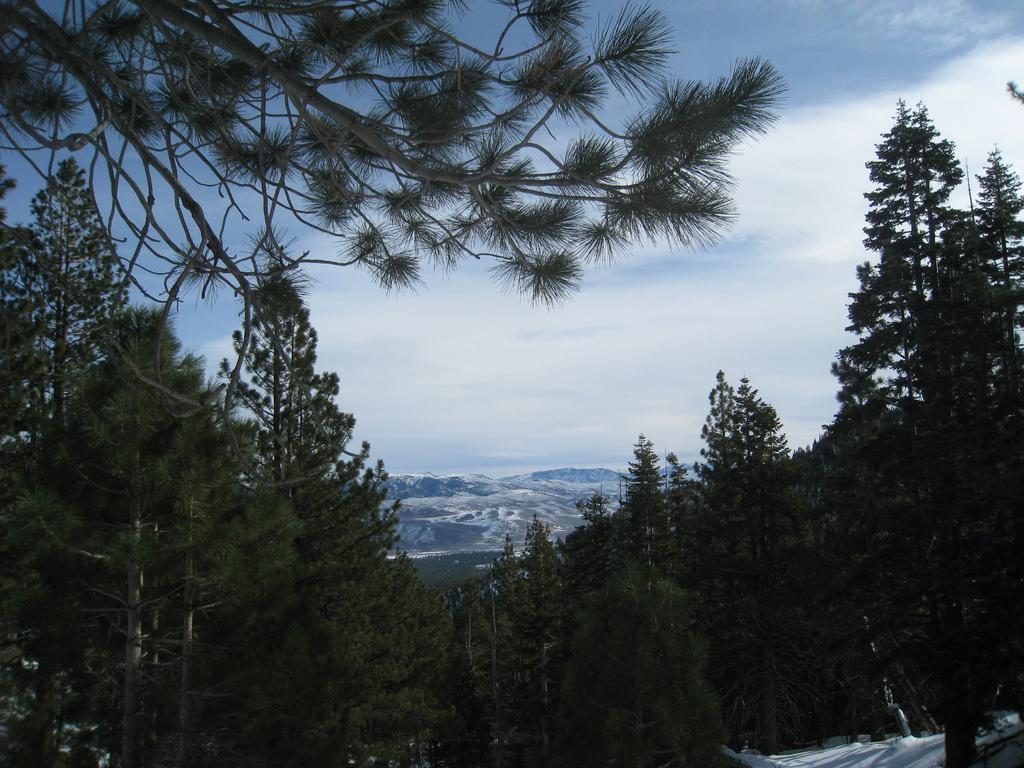What type of vegetation can be seen in the image? There are trees in the image. What else is visible in the sky besides the trees? There are clouds in the image. What part of the natural environment is visible in the image? The sky is visible in the image. What type of vest can be seen hanging from the tree in the image? There is no vest present in the image; it only features trees and clouds. 